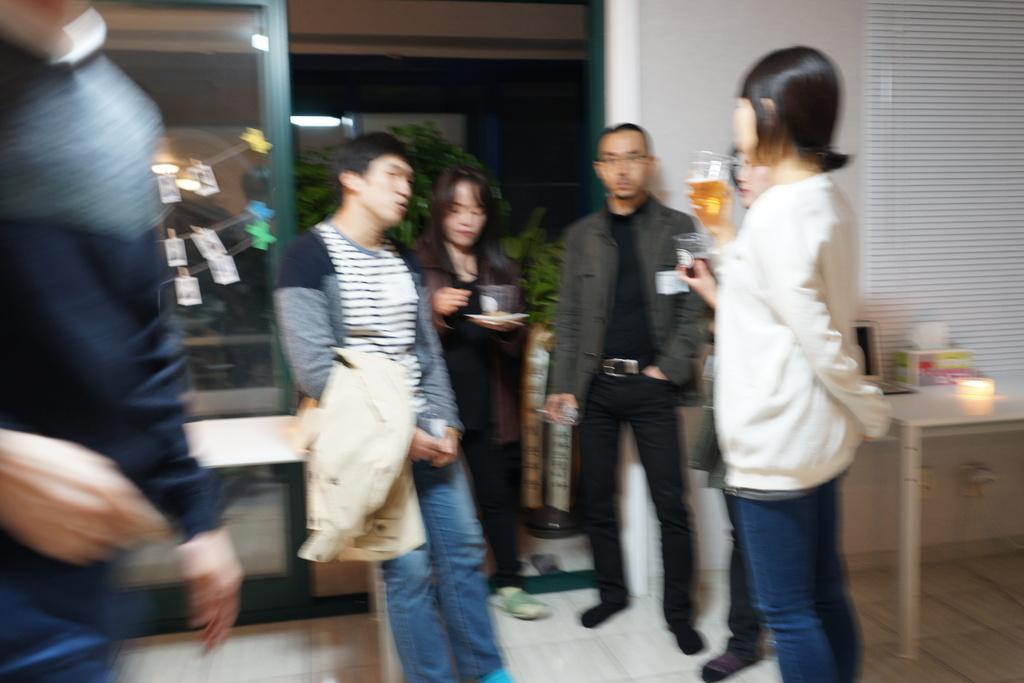Can you describe this image briefly? There are group of people standing. This is a table with few objects on it. I can see a blind curtain hanging. In the background, that looks like a tree. I can see the photos hanging to a rope. This looks like a glass door. 